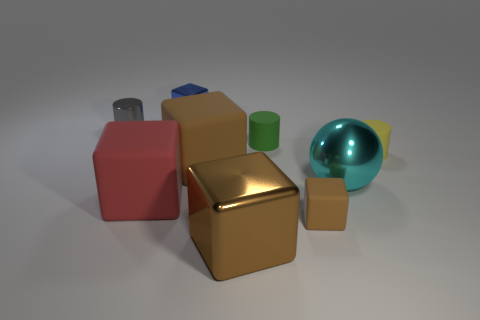Can you describe the lighting in the scene? The lighting in the scene is soft and diffuse, coming from above. It casts gentle shadows underneath each object, indicating that the light source is not too harsh. This type of lighting helps to define the shapes and textures of the objects without creating overpowering highlights or deep shadows. 